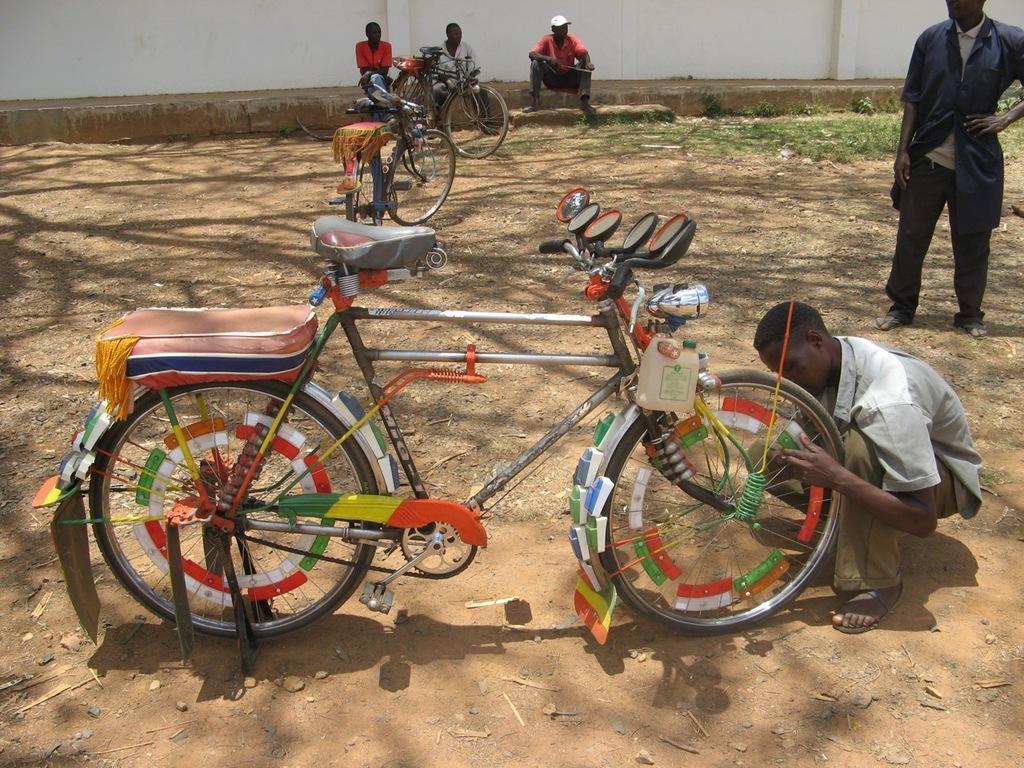How would you summarize this image in a sentence or two? There is a man sitting like squat position,in front of this man we can see bicycle and this man standing. In the background we can see bicycles,wall,grass and there are three people sitting. 